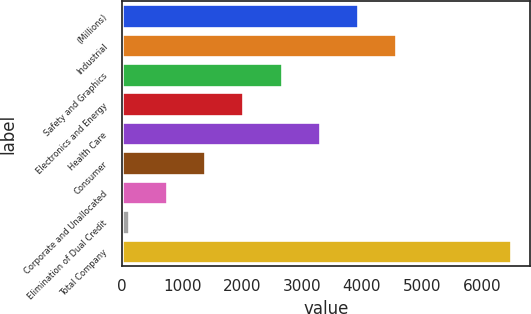Convert chart. <chart><loc_0><loc_0><loc_500><loc_500><bar_chart><fcel>(Millions)<fcel>Industrial<fcel>Safety and Graphics<fcel>Electronics and Energy<fcel>Health Care<fcel>Consumer<fcel>Corporate and Unallocated<fcel>Elimination of Dual Credit<fcel>Total Company<nl><fcel>3933.4<fcel>4570.8<fcel>2658.6<fcel>2021.2<fcel>3296<fcel>1383.8<fcel>746.4<fcel>109<fcel>6483<nl></chart> 